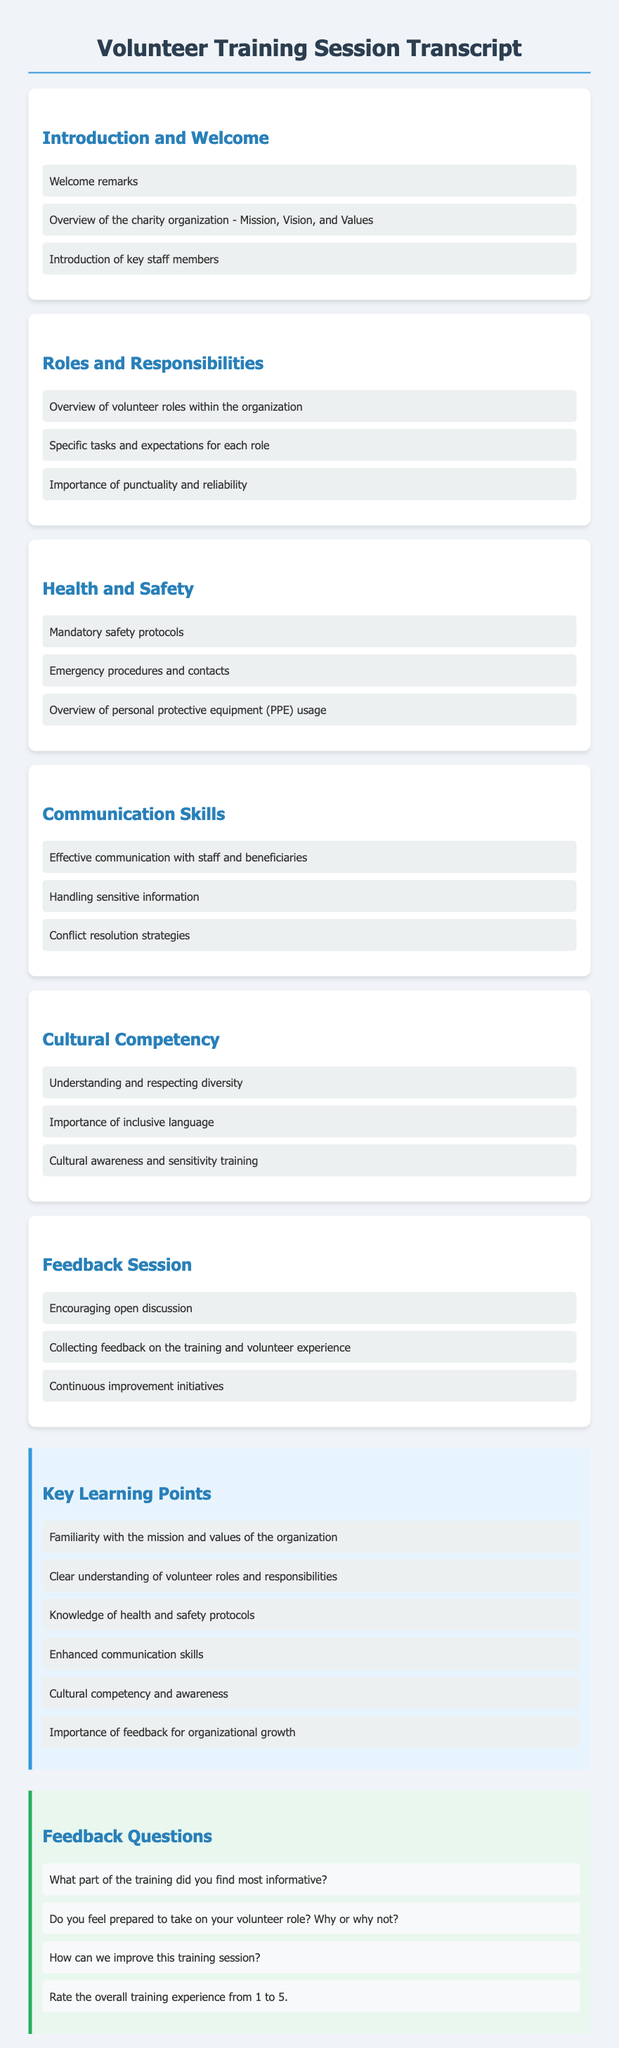What is the mission of the organization? The mission of the organization is mentioned in the overview section, providing a foundation for the volunteer roles.
Answer: Mission What is one of the key expectations for volunteers? Punctuality and reliability are highlighted as important expectations for volunteers in their roles.
Answer: Punctuality What is covered in the Health and Safety section? The Health and Safety section includes mandatory safety protocols, emergency procedures, and PPE usage.
Answer: Safety protocols What type of communication is emphasized in the training? Effective communication with staff and beneficiaries is emphasized as a key skill during the training.
Answer: Effective communication How many key learning points are listed? The document outlines six key learning points that volunteers should take away from the training session.
Answer: Six What feedback question asks about preparedness? One feedback question specifically asks if participants feel prepared to take on their volunteer role.
Answer: Prepared Which section talks about respecting diversity? The Cultural Competency section discusses understanding and respecting diversity among volunteers and beneficiaries.
Answer: Cultural Competency What is encouraged during the Feedback Session? Open discussion is encouraged during the Feedback Session to facilitate feedback collection.
Answer: Open discussion On a scale of 1 to 5, how is the overall training experience rated? Participants are asked to rate the overall training experience on a scale from 1 to 5.
Answer: 1 to 5 